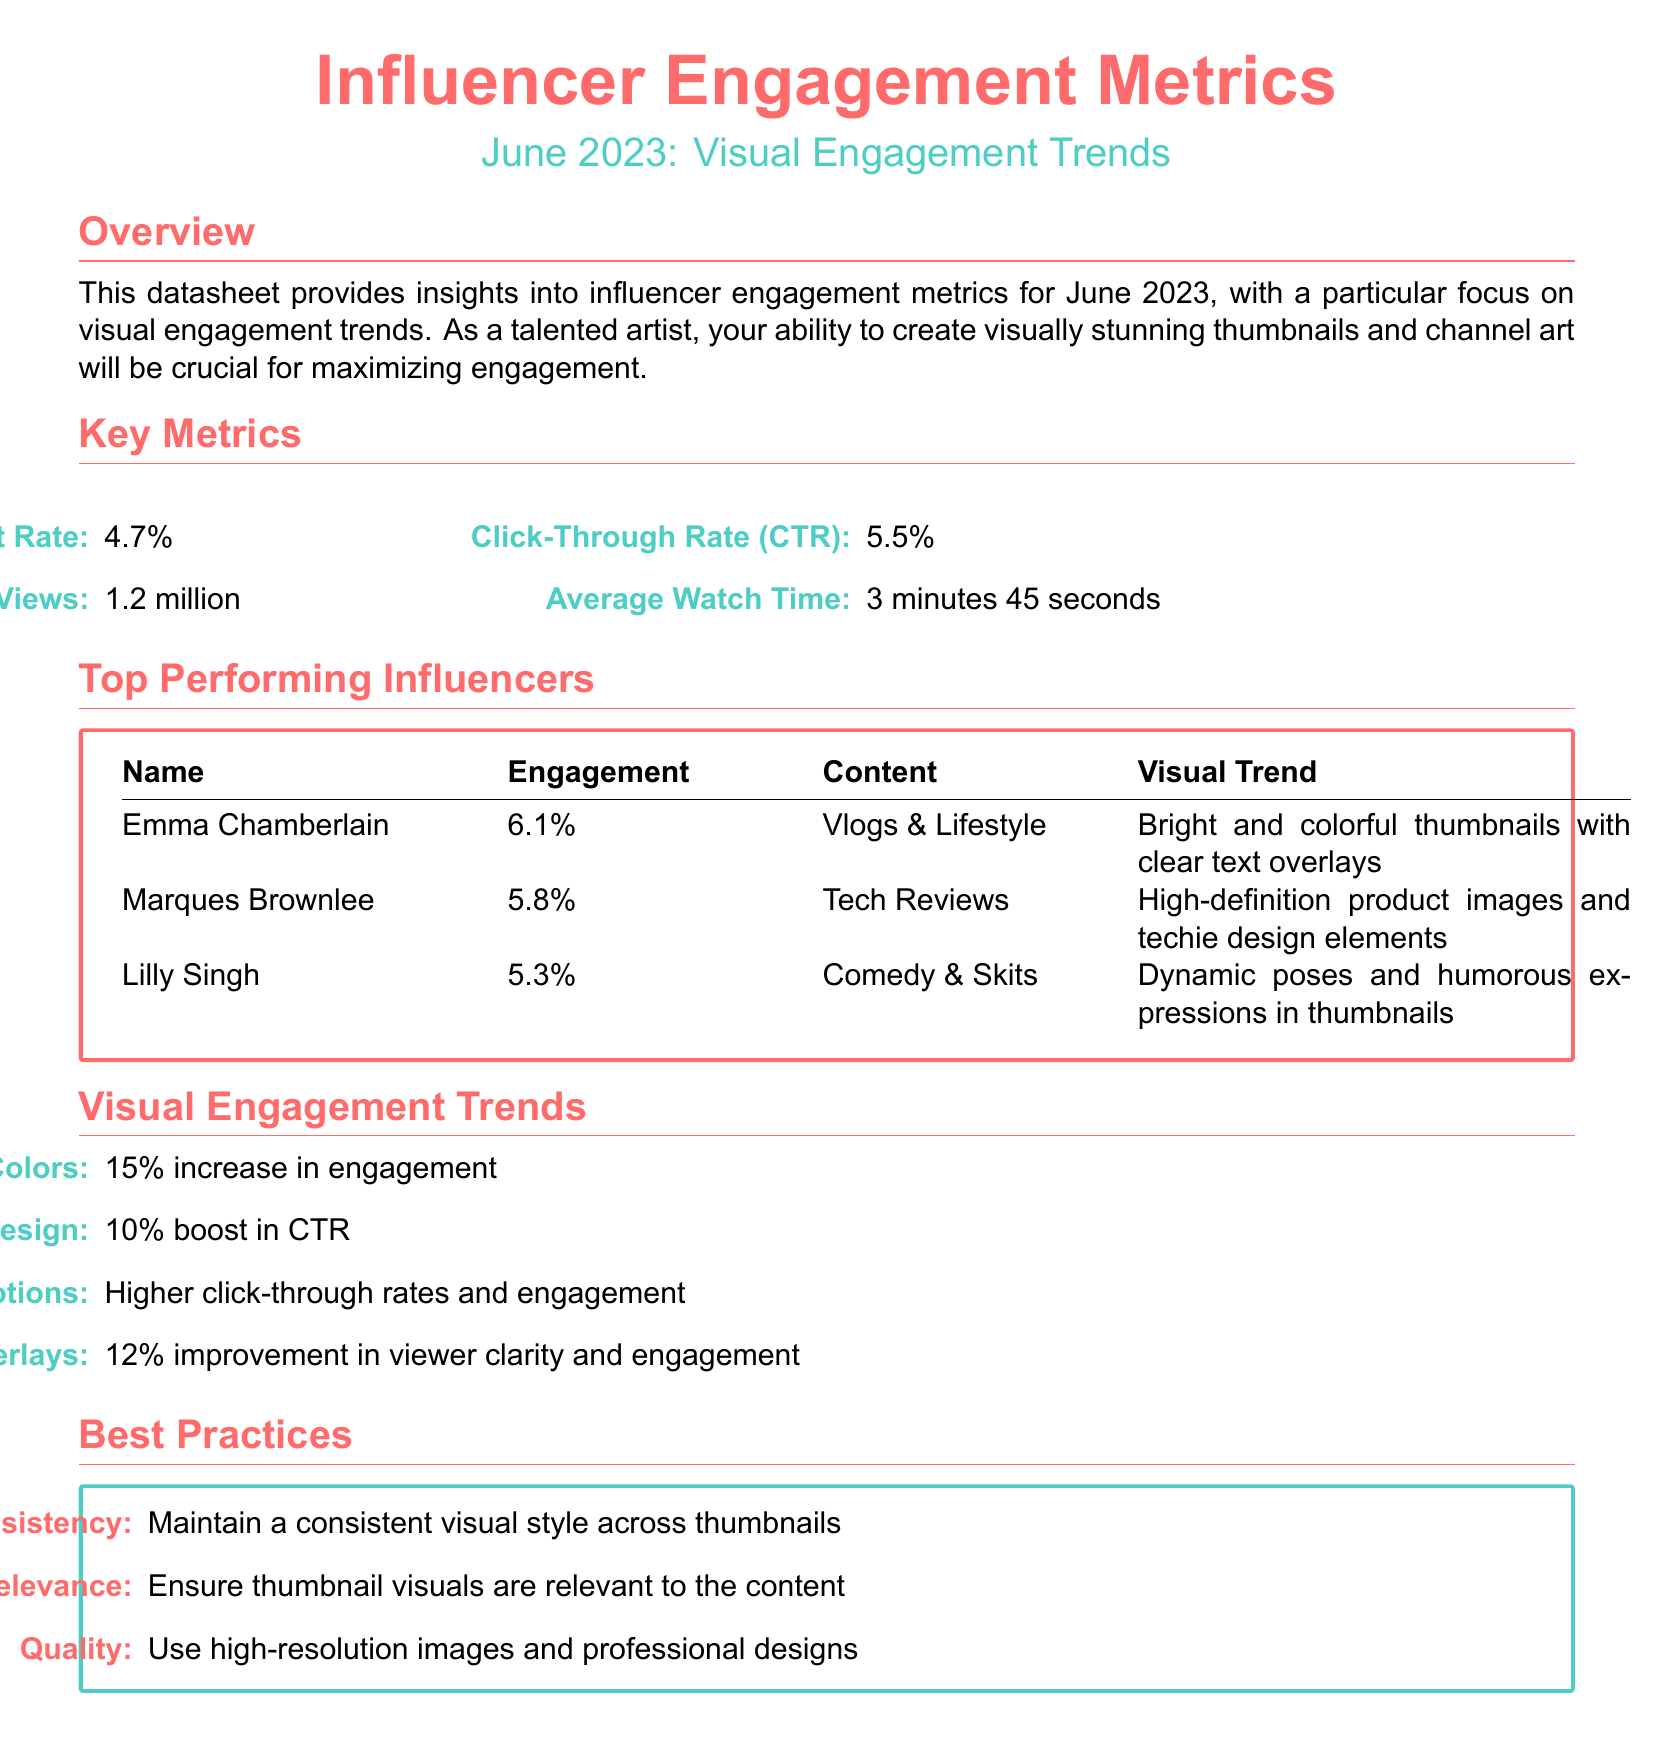What is the average engagement rate? The average engagement rate is provided in the key metrics section of the document as 4.7%.
Answer: 4.7% What is the click-through rate (CTR)? The CTR is given in the key metrics section as a percentage, specifically 5.5%.
Answer: 5.5% Who is the top-performing influencer in vlogs and lifestyle? The document lists Emma Chamberlain as the top-performing influencer in this category with an engagement rate of 6.1%.
Answer: Emma Chamberlain What visual trend is associated with Marques Brownlee? The document mentions high-definition product images and techie design elements as the visual trend associated with Marques Brownlee.
Answer: High-definition product images What improvement does text overlays provide in engagement? The document states that text overlays lead to a 12% improvement in viewer clarity and engagement.
Answer: 12% Which color trend shows a 15% increase in engagement? The data indicates that high contrast colors are associated with a 15% increase in engagement.
Answer: High Contrast Colors What visual style should be maintained according to best practices? The best practices section states that consistency is essential for maintaining a visual style.
Answer: Consistency How long is the average watch time? The average watch time is specifically mentioned in the key metrics as 3 minutes 45 seconds.
Answer: 3 minutes 45 seconds What is the percentage increase in engagement for minimalist design? The document states that minimalist design provides a 10% boost in click-through rates.
Answer: 10% 